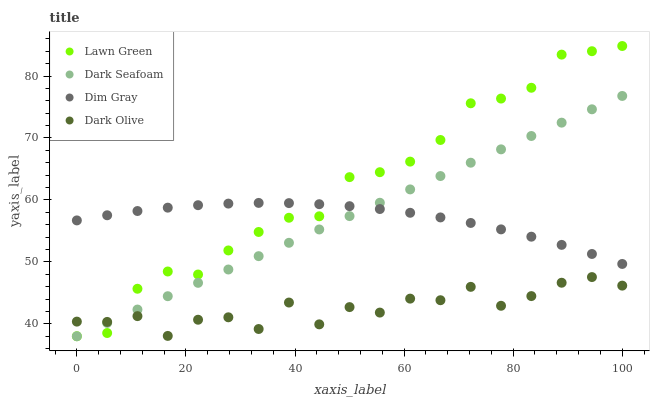Does Dark Olive have the minimum area under the curve?
Answer yes or no. Yes. Does Lawn Green have the maximum area under the curve?
Answer yes or no. Yes. Does Dark Seafoam have the minimum area under the curve?
Answer yes or no. No. Does Dark Seafoam have the maximum area under the curve?
Answer yes or no. No. Is Dark Seafoam the smoothest?
Answer yes or no. Yes. Is Dark Olive the roughest?
Answer yes or no. Yes. Is Lawn Green the smoothest?
Answer yes or no. No. Is Lawn Green the roughest?
Answer yes or no. No. Does Lawn Green have the lowest value?
Answer yes or no. Yes. Does Dim Gray have the lowest value?
Answer yes or no. No. Does Lawn Green have the highest value?
Answer yes or no. Yes. Does Dark Seafoam have the highest value?
Answer yes or no. No. Is Dark Olive less than Dim Gray?
Answer yes or no. Yes. Is Dim Gray greater than Dark Olive?
Answer yes or no. Yes. Does Dark Seafoam intersect Dim Gray?
Answer yes or no. Yes. Is Dark Seafoam less than Dim Gray?
Answer yes or no. No. Is Dark Seafoam greater than Dim Gray?
Answer yes or no. No. Does Dark Olive intersect Dim Gray?
Answer yes or no. No. 